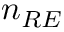<formula> <loc_0><loc_0><loc_500><loc_500>n _ { R E }</formula> 